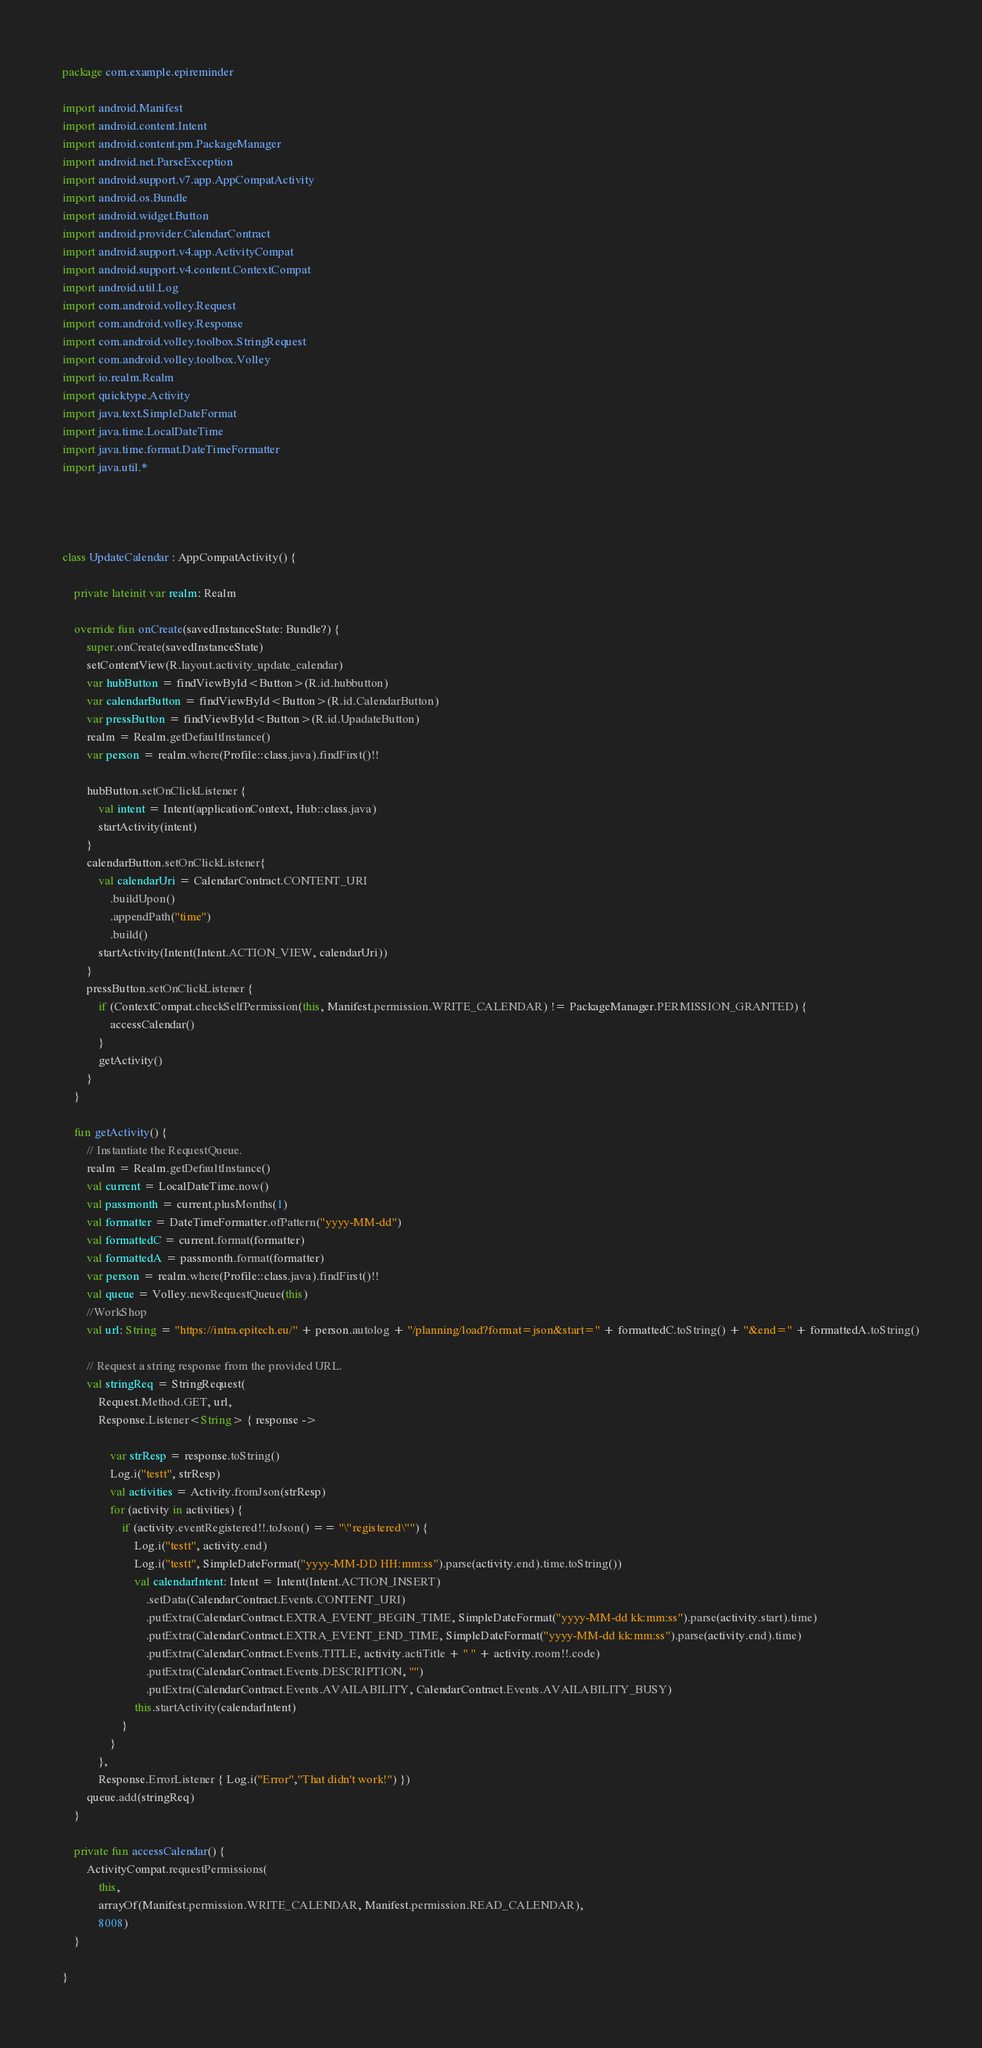<code> <loc_0><loc_0><loc_500><loc_500><_Kotlin_>package com.example.epireminder

import android.Manifest
import android.content.Intent
import android.content.pm.PackageManager
import android.net.ParseException
import android.support.v7.app.AppCompatActivity
import android.os.Bundle
import android.widget.Button
import android.provider.CalendarContract
import android.support.v4.app.ActivityCompat
import android.support.v4.content.ContextCompat
import android.util.Log
import com.android.volley.Request
import com.android.volley.Response
import com.android.volley.toolbox.StringRequest
import com.android.volley.toolbox.Volley
import io.realm.Realm
import quicktype.Activity
import java.text.SimpleDateFormat
import java.time.LocalDateTime
import java.time.format.DateTimeFormatter
import java.util.*




class UpdateCalendar : AppCompatActivity() {

    private lateinit var realm: Realm

    override fun onCreate(savedInstanceState: Bundle?) {
        super.onCreate(savedInstanceState)
        setContentView(R.layout.activity_update_calendar)
        var hubButton = findViewById<Button>(R.id.hubbutton)
        var calendarButton = findViewById<Button>(R.id.CalendarButton)
        var pressButton = findViewById<Button>(R.id.UpadateButton)
        realm = Realm.getDefaultInstance()
        var person = realm.where(Profile::class.java).findFirst()!!

        hubButton.setOnClickListener {
            val intent = Intent(applicationContext, Hub::class.java)
            startActivity(intent)
        }
        calendarButton.setOnClickListener{
            val calendarUri = CalendarContract.CONTENT_URI
                .buildUpon()
                .appendPath("time")
                .build()
            startActivity(Intent(Intent.ACTION_VIEW, calendarUri))
        }
        pressButton.setOnClickListener {
            if (ContextCompat.checkSelfPermission(this, Manifest.permission.WRITE_CALENDAR) != PackageManager.PERMISSION_GRANTED) {
                accessCalendar()
            }
            getActivity()
        }
    }

    fun getActivity() {
        // Instantiate the RequestQueue.
        realm = Realm.getDefaultInstance()
        val current = LocalDateTime.now()
        val passmonth = current.plusMonths(1)
        val formatter = DateTimeFormatter.ofPattern("yyyy-MM-dd")
        val formattedC = current.format(formatter)
        val formattedA = passmonth.format(formatter)
        var person = realm.where(Profile::class.java).findFirst()!!
        val queue = Volley.newRequestQueue(this)
        //WorkShop
        val url: String = "https://intra.epitech.eu/" + person.autolog + "/planning/load?format=json&start=" + formattedC.toString() + "&end=" + formattedA.toString()

        // Request a string response from the provided URL.
        val stringReq = StringRequest(
            Request.Method.GET, url,
            Response.Listener<String> { response ->

                var strResp = response.toString()
                Log.i("testt", strResp)
                val activities = Activity.fromJson(strResp)
                for (activity in activities) {
                    if (activity.eventRegistered!!.toJson() == "\"registered\"") {
                        Log.i("testt", activity.end)
                        Log.i("testt", SimpleDateFormat("yyyy-MM-DD HH:mm:ss").parse(activity.end).time.toString())
                        val calendarIntent: Intent = Intent(Intent.ACTION_INSERT)
                            .setData(CalendarContract.Events.CONTENT_URI)
                            .putExtra(CalendarContract.EXTRA_EVENT_BEGIN_TIME, SimpleDateFormat("yyyy-MM-dd kk:mm:ss").parse(activity.start).time)
                            .putExtra(CalendarContract.EXTRA_EVENT_END_TIME, SimpleDateFormat("yyyy-MM-dd kk:mm:ss").parse(activity.end).time)
                            .putExtra(CalendarContract.Events.TITLE, activity.actiTitle + " " + activity.room!!.code)
                            .putExtra(CalendarContract.Events.DESCRIPTION, "")
                            .putExtra(CalendarContract.Events.AVAILABILITY, CalendarContract.Events.AVAILABILITY_BUSY)
                        this.startActivity(calendarIntent)
                    }
                }
            },
            Response.ErrorListener { Log.i("Error","That didn't work!") })
        queue.add(stringReq)
    }

    private fun accessCalendar() {
        ActivityCompat.requestPermissions(
            this,
            arrayOf(Manifest.permission.WRITE_CALENDAR, Manifest.permission.READ_CALENDAR),
            8008)
    }

}
</code> 